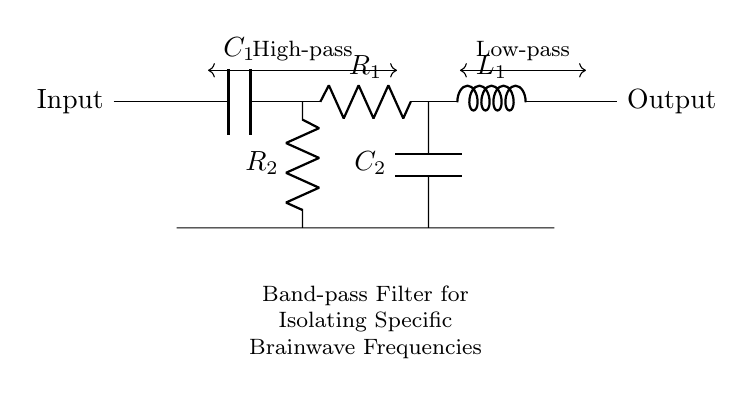What type of filter is represented in the diagram? The diagram illustrates a band-pass filter, which is specifically designed to allow frequencies within a certain range to pass through while attenuating frequencies outside that range. This is indicated by the labels "High-pass" and "Low-pass" that illustrate the filter's function.
Answer: Band-pass filter What components are used in this filter? The circuit includes a capacitor labeled C1, a resistor labeled R1, an inductor labeled L1, a resistor labeled R2, and a capacitor labeled C2. These components work together to establish the filter's characteristics.
Answer: Capacitors, Resistors, Inductor How many capacitors are present in the circuit? There are two capacitors in the circuit: C1 and C2. The symbols and labels on the diagram clearly show the two components and their connection points.
Answer: Two What is the role of the inductor in this circuit? The inductor L1 primarily serves to block high-frequency signals, allowing the desired band of frequencies to pass while rejecting higher frequencies. This role is critical in shaping the filter's characteristics.
Answer: Low-pass Which components determine the cutoff frequencies? The combination of the resistors R1 and R2 with the capacitors C1 and C2 determines the cutoff frequencies of the filter. The values of these components define the specific frequency range that the circuit will isolate and work with.
Answer: Resistors and Capacitors What is the function of the labeled "High-pass" and "Low-pass" sections? The labeled sections indicate the frequency response characteristics of the filter. The "High-pass" section denotes that frequencies above a certain threshold will pass, and the "Low-pass" section indicates that frequencies below another threshold will also be passed. This combination is what characterizes the band-pass filter.
Answer: Frequency response How is the input and output of the filter connected? The input is connected to one side of C1, while the output is taken from the other side of L1, indicating the flow of signals through the circuit from the input to the output after filtering. This connection facilitates the desired frequency selection.
Answer: Input to C1, output from L1 